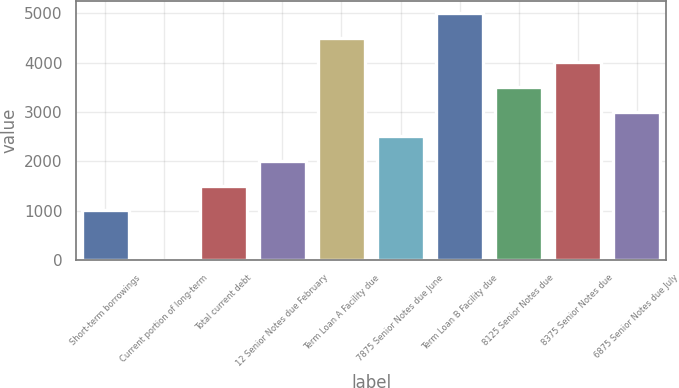Convert chart. <chart><loc_0><loc_0><loc_500><loc_500><bar_chart><fcel>Short-term borrowings<fcel>Current portion of long-term<fcel>Total current debt<fcel>12 Senior Notes due February<fcel>Term Loan A Facility due<fcel>7875 Senior Notes due June<fcel>Term Loan B Facility due<fcel>8125 Senior Notes due<fcel>8375 Senior Notes due<fcel>6875 Senior Notes due July<nl><fcel>1002.14<fcel>1.9<fcel>1502.26<fcel>2002.38<fcel>4502.98<fcel>2502.5<fcel>5003.1<fcel>3502.74<fcel>4002.86<fcel>3002.62<nl></chart> 